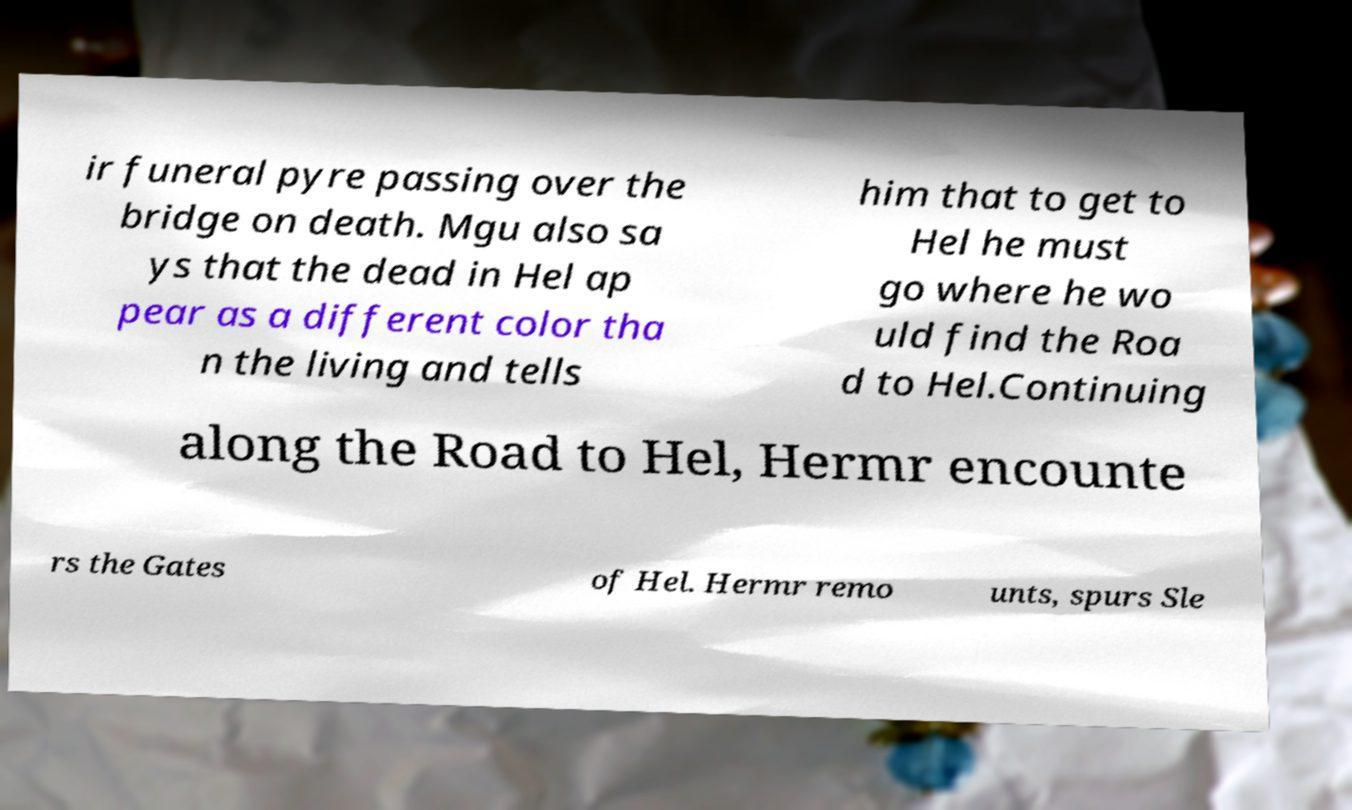For documentation purposes, I need the text within this image transcribed. Could you provide that? ir funeral pyre passing over the bridge on death. Mgu also sa ys that the dead in Hel ap pear as a different color tha n the living and tells him that to get to Hel he must go where he wo uld find the Roa d to Hel.Continuing along the Road to Hel, Hermr encounte rs the Gates of Hel. Hermr remo unts, spurs Sle 